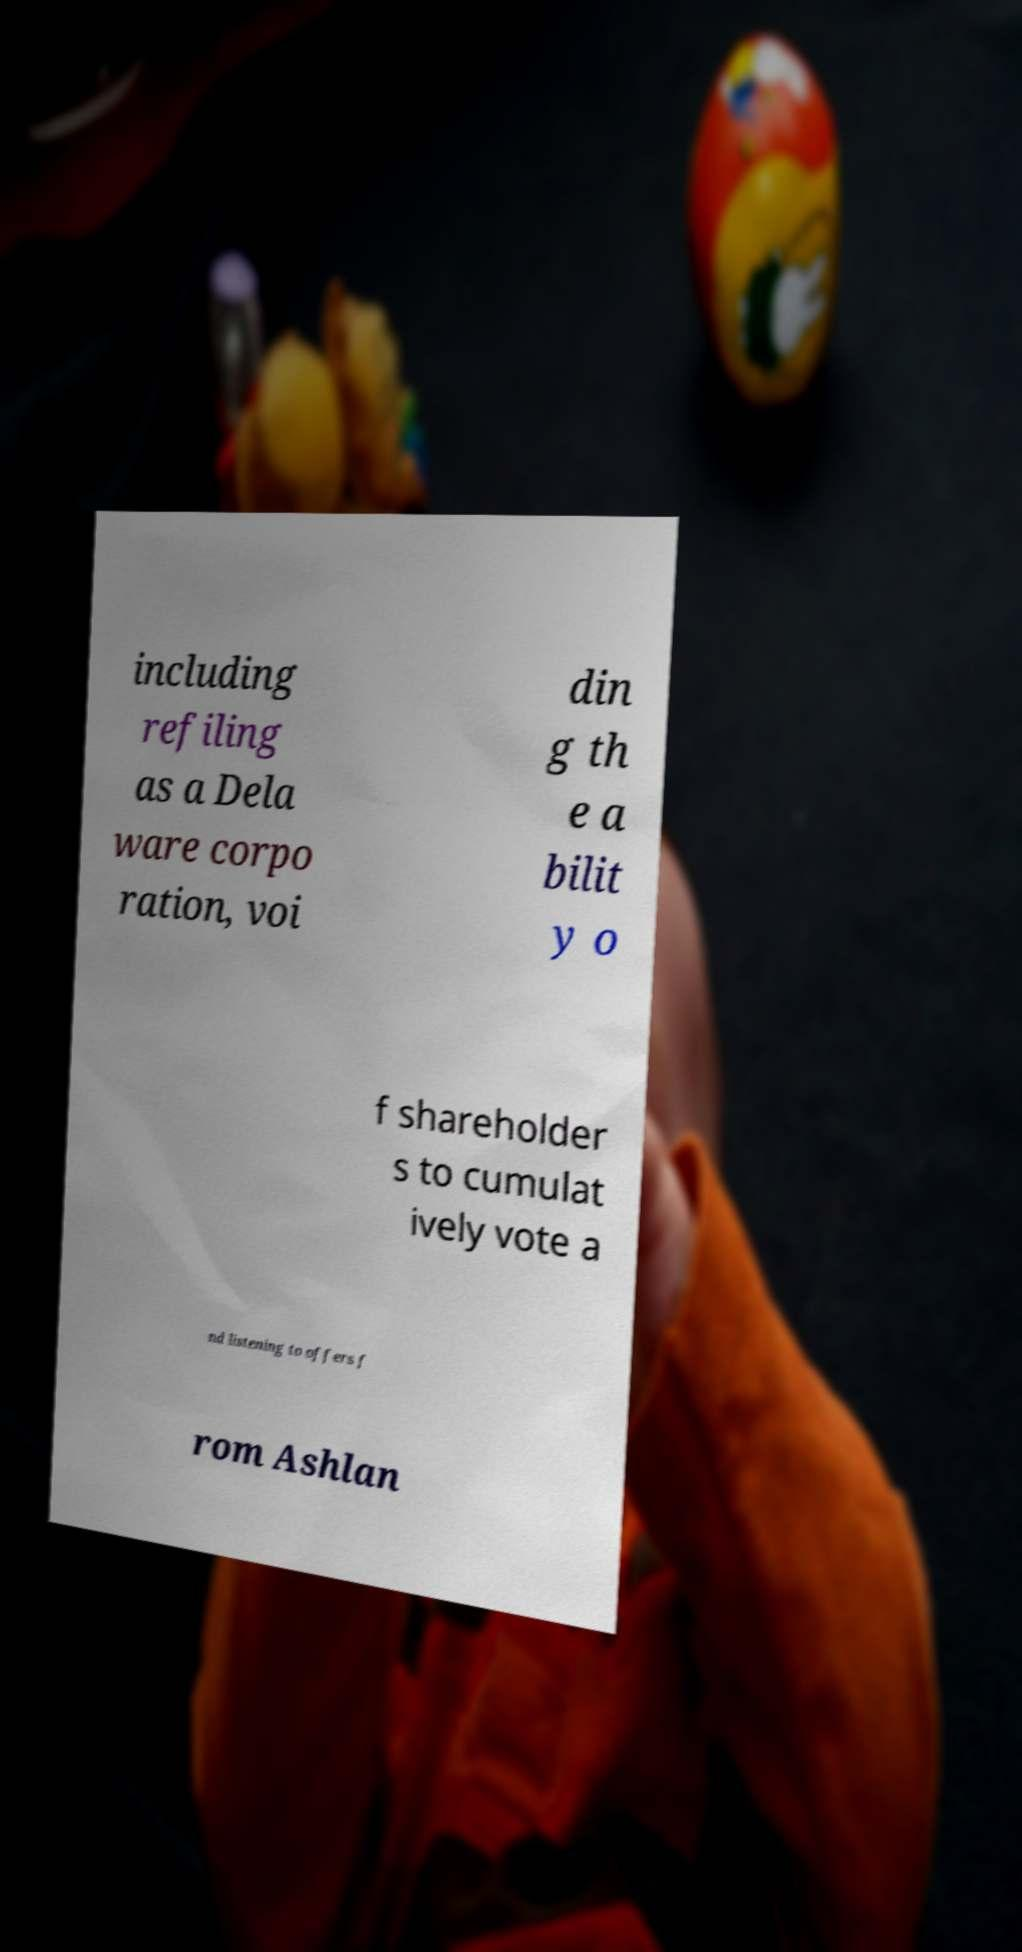Can you read and provide the text displayed in the image?This photo seems to have some interesting text. Can you extract and type it out for me? including refiling as a Dela ware corpo ration, voi din g th e a bilit y o f shareholder s to cumulat ively vote a nd listening to offers f rom Ashlan 